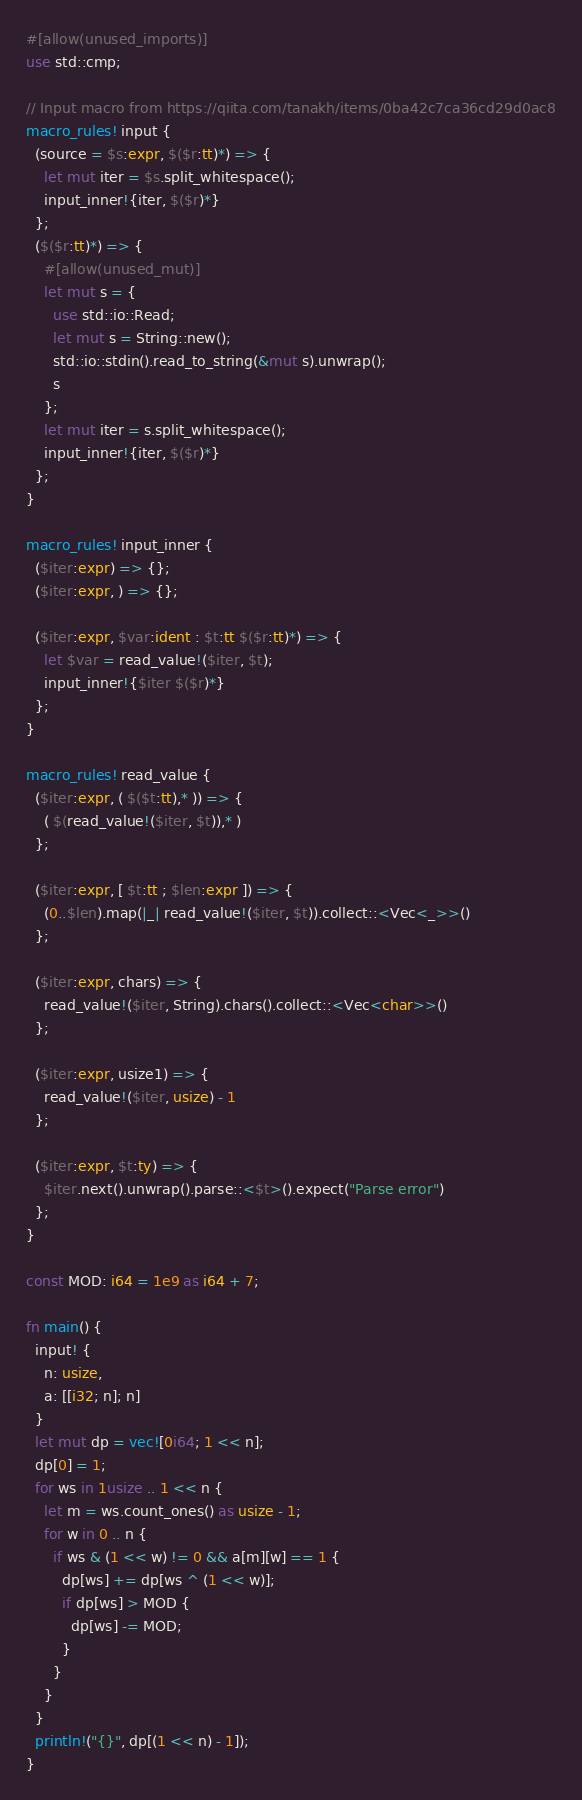Convert code to text. <code><loc_0><loc_0><loc_500><loc_500><_Rust_>#[allow(unused_imports)]
use std::cmp;

// Input macro from https://qiita.com/tanakh/items/0ba42c7ca36cd29d0ac8
macro_rules! input {
  (source = $s:expr, $($r:tt)*) => {
    let mut iter = $s.split_whitespace();
    input_inner!{iter, $($r)*}
  };
  ($($r:tt)*) => {
    #[allow(unused_mut)]
    let mut s = {
      use std::io::Read;
      let mut s = String::new();
      std::io::stdin().read_to_string(&mut s).unwrap();
      s
    };
    let mut iter = s.split_whitespace();
    input_inner!{iter, $($r)*}
  };
}

macro_rules! input_inner {
  ($iter:expr) => {};
  ($iter:expr, ) => {};

  ($iter:expr, $var:ident : $t:tt $($r:tt)*) => {
    let $var = read_value!($iter, $t);
    input_inner!{$iter $($r)*}
  };
}

macro_rules! read_value {
  ($iter:expr, ( $($t:tt),* )) => {
    ( $(read_value!($iter, $t)),* )
  };

  ($iter:expr, [ $t:tt ; $len:expr ]) => {
    (0..$len).map(|_| read_value!($iter, $t)).collect::<Vec<_>>()
  };

  ($iter:expr, chars) => {
    read_value!($iter, String).chars().collect::<Vec<char>>()
  };

  ($iter:expr, usize1) => {
    read_value!($iter, usize) - 1
  };

  ($iter:expr, $t:ty) => {
    $iter.next().unwrap().parse::<$t>().expect("Parse error")
  };
}

const MOD: i64 = 1e9 as i64 + 7;

fn main() {
  input! {
    n: usize,
    a: [[i32; n]; n]
  }
  let mut dp = vec![0i64; 1 << n];
  dp[0] = 1;
  for ws in 1usize .. 1 << n {
    let m = ws.count_ones() as usize - 1;
    for w in 0 .. n {
      if ws & (1 << w) != 0 && a[m][w] == 1 {
        dp[ws] += dp[ws ^ (1 << w)];
        if dp[ws] > MOD {
          dp[ws] -= MOD;
        }
      }
    }
  }
  println!("{}", dp[(1 << n) - 1]);
}
</code> 